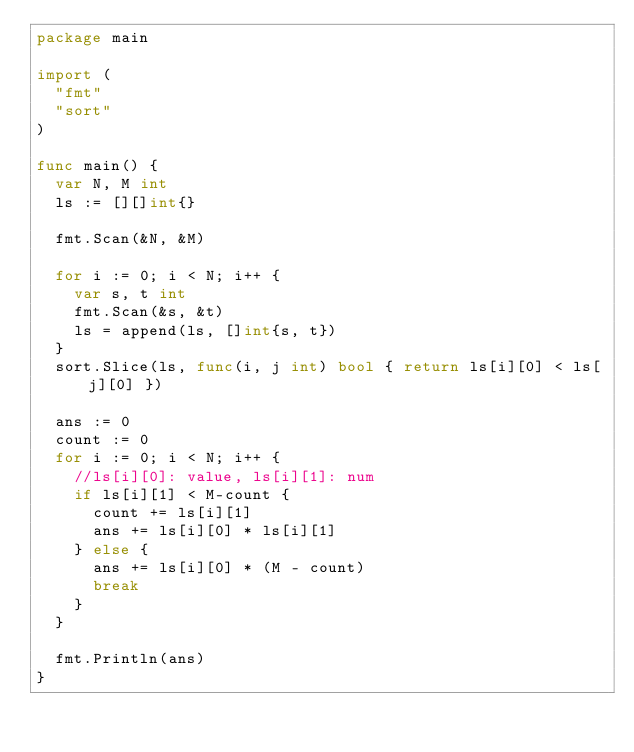Convert code to text. <code><loc_0><loc_0><loc_500><loc_500><_Go_>package main

import (
	"fmt"
	"sort"
)

func main() {
	var N, M int
	ls := [][]int{}

	fmt.Scan(&N, &M)

	for i := 0; i < N; i++ {
		var s, t int
		fmt.Scan(&s, &t)
		ls = append(ls, []int{s, t})
	}
	sort.Slice(ls, func(i, j int) bool { return ls[i][0] < ls[j][0] })

	ans := 0
	count := 0
	for i := 0; i < N; i++ {
		//ls[i][0]: value, ls[i][1]: num
		if ls[i][1] < M-count {
			count += ls[i][1]
			ans += ls[i][0] * ls[i][1]
		} else {
			ans += ls[i][0] * (M - count)
			break
		}
	}

	fmt.Println(ans)
}
</code> 